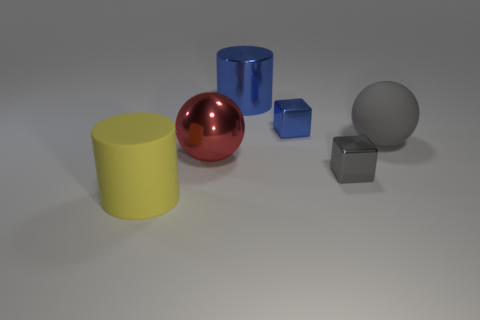Subtract all large red objects. Subtract all yellow cylinders. How many objects are left? 4 Add 2 large yellow things. How many large yellow things are left? 3 Add 2 yellow cylinders. How many yellow cylinders exist? 3 Add 4 small cyan rubber things. How many objects exist? 10 Subtract all blue cylinders. How many cylinders are left? 1 Subtract 1 gray balls. How many objects are left? 5 Subtract all balls. How many objects are left? 4 Subtract 1 balls. How many balls are left? 1 Subtract all brown balls. Subtract all blue cylinders. How many balls are left? 2 Subtract all gray cubes. How many gray balls are left? 1 